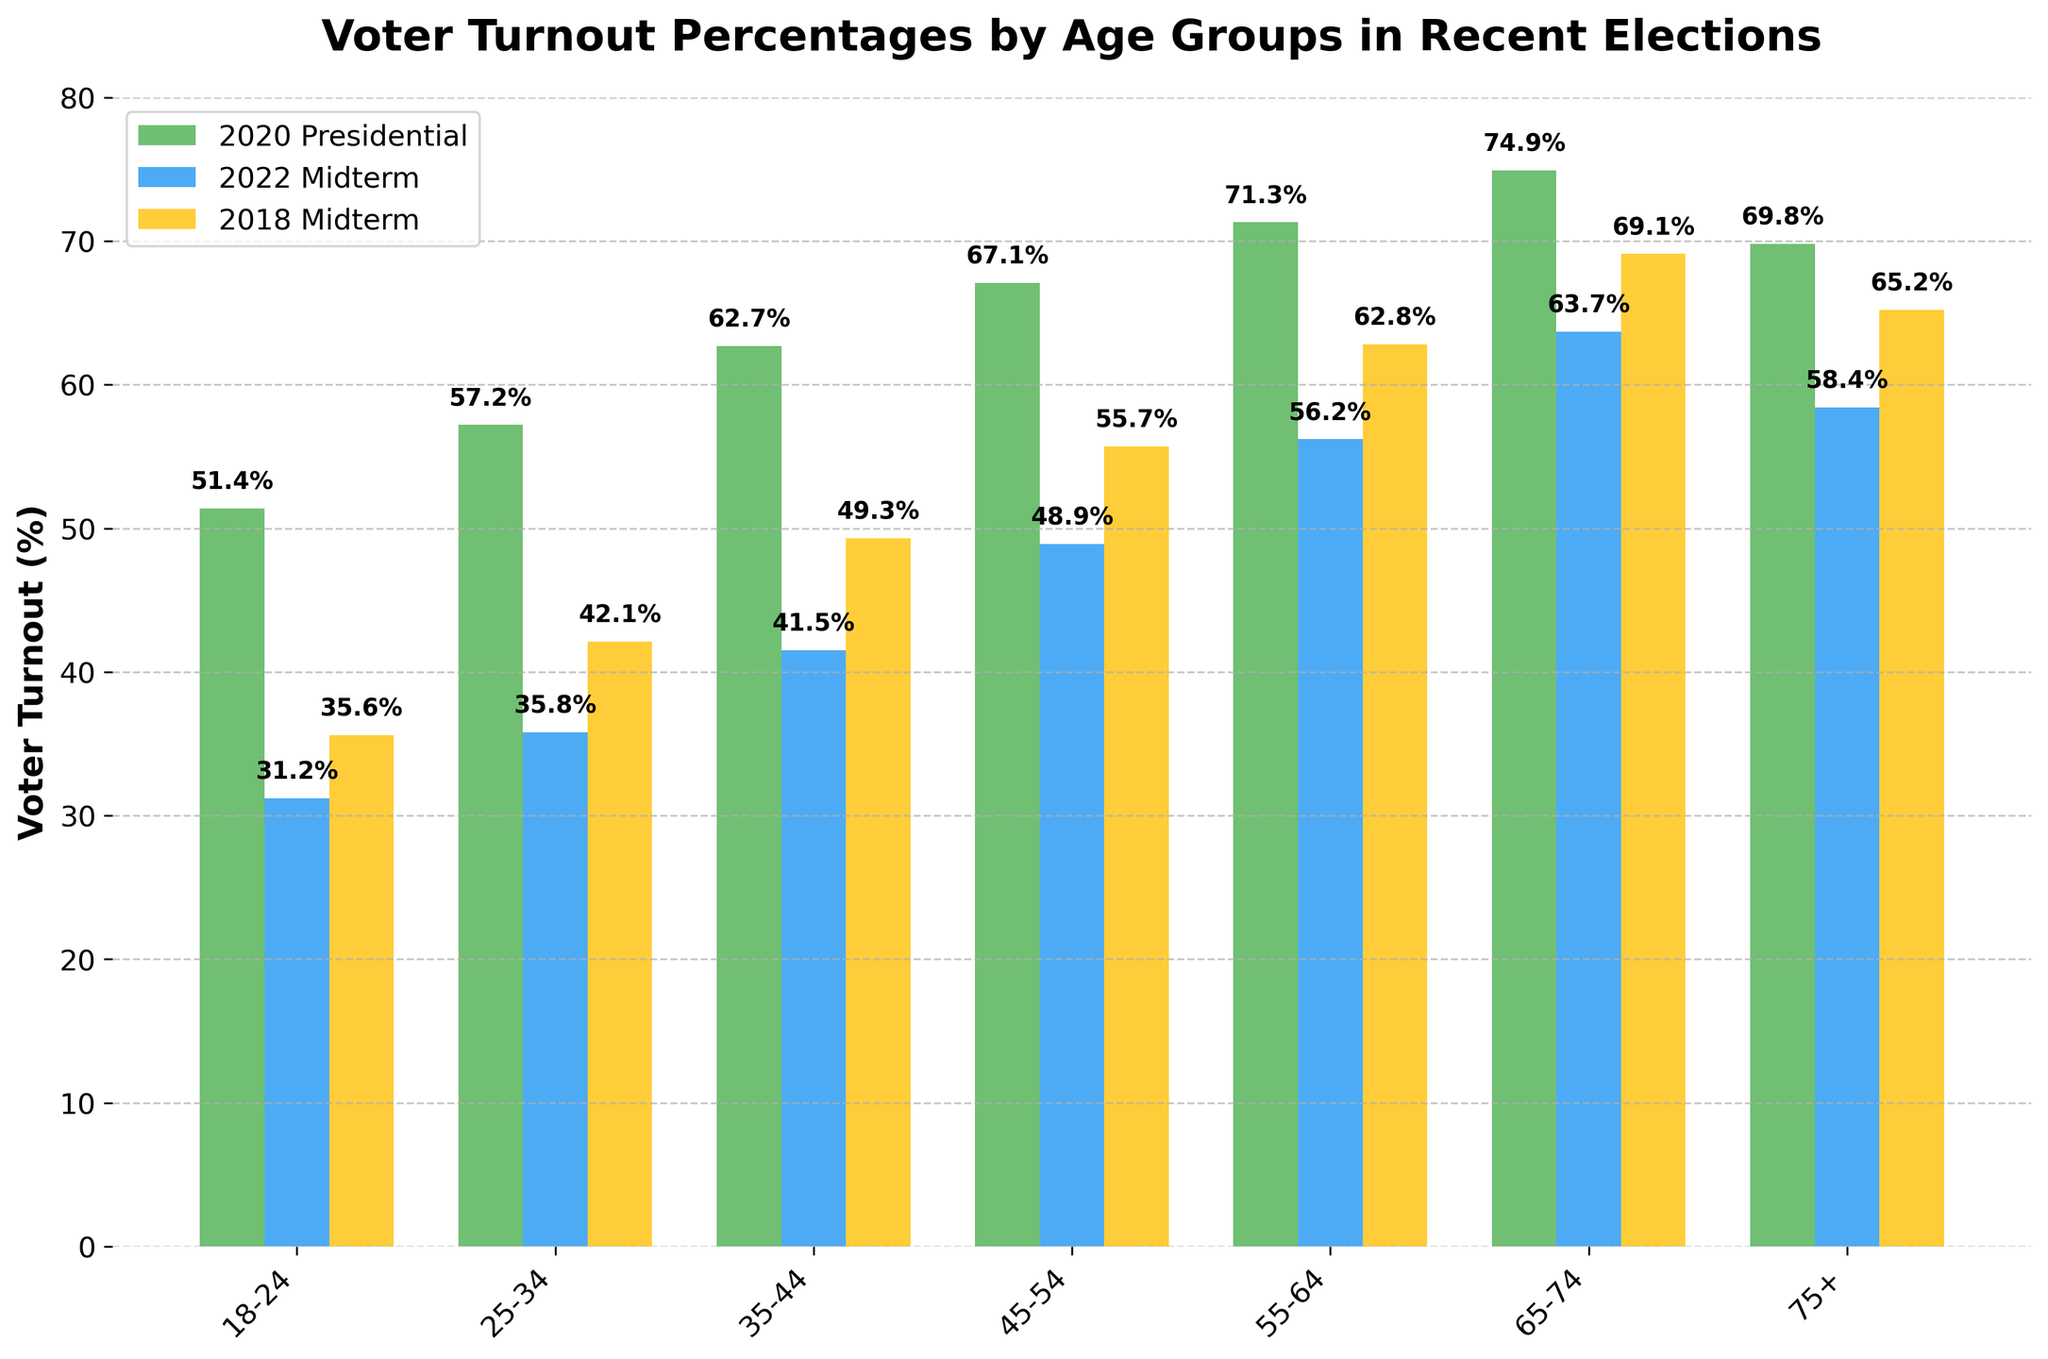What age group had the highest voter turnout in the 2020 Presidential election? The 65-74 age group had the highest voter turnout in the 2020 Presidential election. Their bar extends the highest among the 2020 Presidential election bars.
Answer: 65-74 How did voter turnout for the 18-24 age group in the 2022 Midterm compare to the 2018 Midterm? The 18-24 age group had a lower voter turnout in the 2022 Midterm compared to the 2018 Midterm. Their 2022 Midterm bar is shorter than their 2018 Midterm bar.
Answer: Lower What is the average voter turnout percentage for the 45-54 age group across all three elections? Add the turnout percentages for the 45-54 age group across all three elections: 67.1% (2020 Presidential), 48.9% (2022 Midterm), and 55.7% (2018 Midterm). The sum is 171.7%, and the average is 171.7 / 3 = 57.23%.
Answer: 57.23% Which election had the highest voter turnout for the 25-34 age group? The 2020 Presidential election had the highest voter turnout for the 25-34 age group. The bar for the 2020 Presidential election is higher than the bars for the 2022 Midterm and 2018 Midterm elections in this age group.
Answer: 2020 Presidential Which age group had the smallest change in voter turnout between the 2018 and 2022 Midterm elections? The 75+ age group had the smallest change in voter turnout between the 2018 and 2022 Midterm elections. Their voter turnout changed from 65.2% in 2018 to 58.4% in 2022, a difference of 6.8 percentage points.
Answer: 75+ By how many percentage points did voter turnout increase for the 55-64 age group from the 2018 Midterm to the 2020 Presidential election? The voter turnout for the 55-64 age group increased from 62.8% in the 2018 Midterm election to 71.3% in the 2020 Presidential election. So, the increase is 71.3 - 62.8 = 8.5 percentage points.
Answer: 8.5 Which age group had the lowest growth in voter turnout from the 2018 Midterm to the 2020 Presidential election? The 75+ age group had the lowest growth in voter turnout, increasing from 65.2% in the 2018 Midterm to 69.8% in the 2020 Presidential election, a growth of 4.6 percentage points.
Answer: 75+ What difference in turnout is observed for the 35-44 age group between the 2020 Presidential and 2022 Midterm elections? The voter turnout for the 35-44 age group was 62.7% in the 2020 Presidential election and 41.5% in the 2022 Midterm election. The difference is 62.7 - 41.5 = 21.2 percentage points.
Answer: 21.2 Which age group showed the greatest decline in voter turnout from the 2020 Presidential election to the 2022 Midterm election? The 18-24 age group showed the greatest decline, going from 51.4% in the 2020 Presidential election to 31.2% in the 2022 Midterm election, a decline of 20.2 percentage points.
Answer: 18-24 